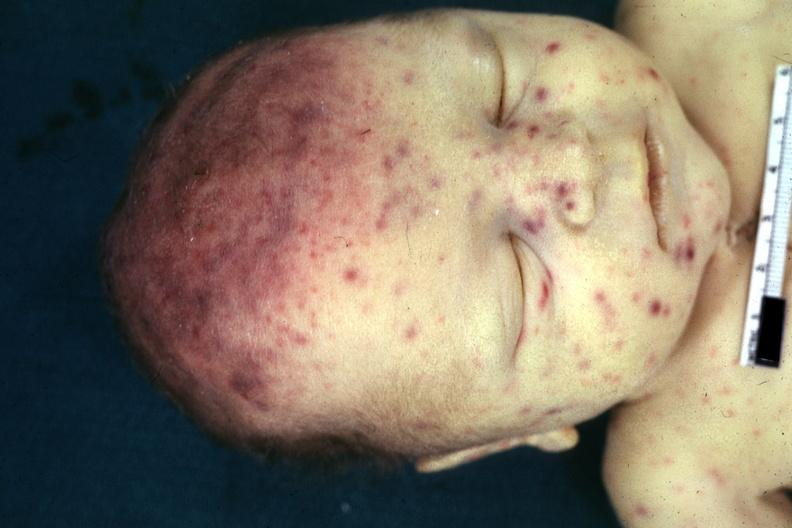where is this?
Answer the question using a single word or phrase. Skin 